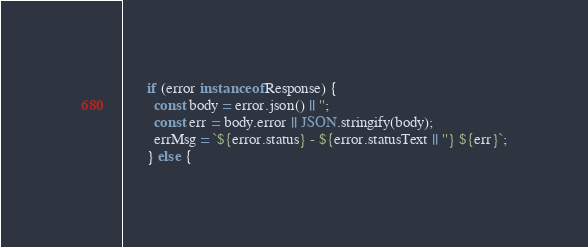Convert code to text. <code><loc_0><loc_0><loc_500><loc_500><_TypeScript_>      if (error instanceof Response) {
        const body = error.json() || '';
        const err = body.error || JSON.stringify(body);
        errMsg = `${error.status} - ${error.statusText || ''} ${err}`;
      } else {</code> 